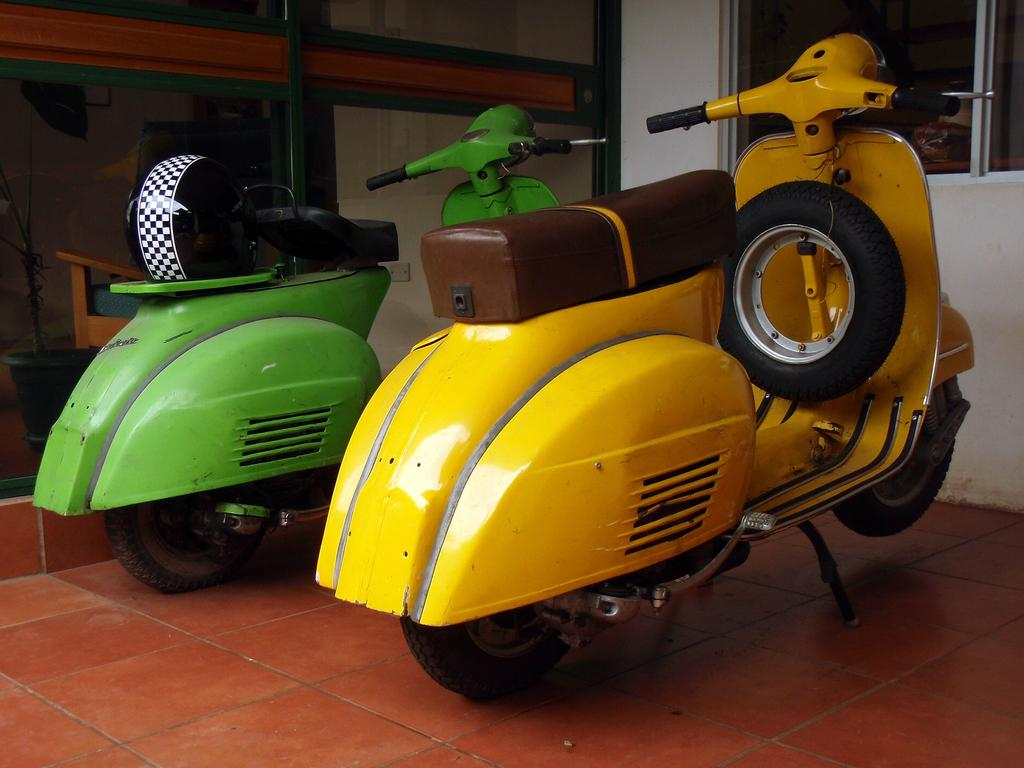What type of vehicles are on the floor in the image? There are scooters on the floor in the image. What safety equipment is present in the image? There is a helmet in the image. What type of architectural feature is visible in the image? There is a wall in the image. What allows natural light to enter the room in the image? There is a window in the image. What type of object is made of glass in the image? There is a glass object in the image. What can be seen in the background of the image? There are objects visible in the background of the image. How much does the scooter weigh in the image? The weight of the scooter cannot be determined from the image alone. What type of care is being provided to the objects in the image? There is no indication of care being provided to the objects in the image. 